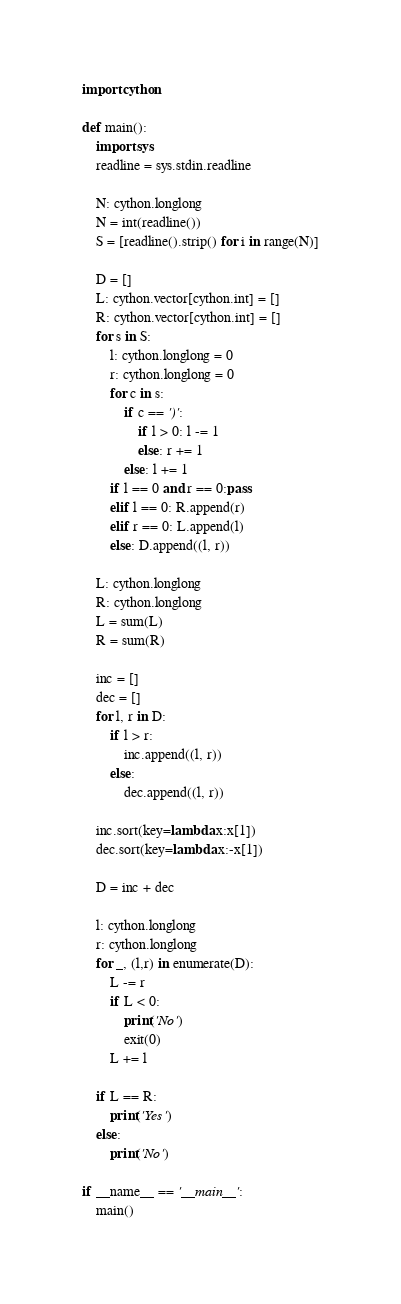Convert code to text. <code><loc_0><loc_0><loc_500><loc_500><_Cython_>import cython
 
def main():
    import sys
    readline = sys.stdin.readline
    
    N: cython.longlong
    N = int(readline())
    S = [readline().strip() for i in range(N)]
    
    D = []
    L: cython.vector[cython.int] = []
    R: cython.vector[cython.int] = []
    for s in S:
        l: cython.longlong = 0
        r: cython.longlong = 0
        for c in s:
            if c == ')':
                if l > 0: l -= 1
                else: r += 1
            else: l += 1
        if l == 0 and r == 0:pass
        elif l == 0: R.append(r)
        elif r == 0: L.append(l)
        else: D.append((l, r))
    
    L: cython.longlong
    R: cython.longlong
    L = sum(L)
    R = sum(R)
    
    inc = []
    dec = []
    for l, r in D:
        if l > r:
            inc.append((l, r))
        else:
            dec.append((l, r))
    
    inc.sort(key=lambda x:x[1])
    dec.sort(key=lambda x:-x[1])
    
    D = inc + dec
    
    l: cython.longlong
    r: cython.longlong
    for _, (l,r) in enumerate(D):
        L -= r
        if L < 0:
            print('No')
            exit(0)
        L += l
    
    if L == R:
        print('Yes')
    else:
        print('No')
 
if __name__ == '__main__':
    main()</code> 